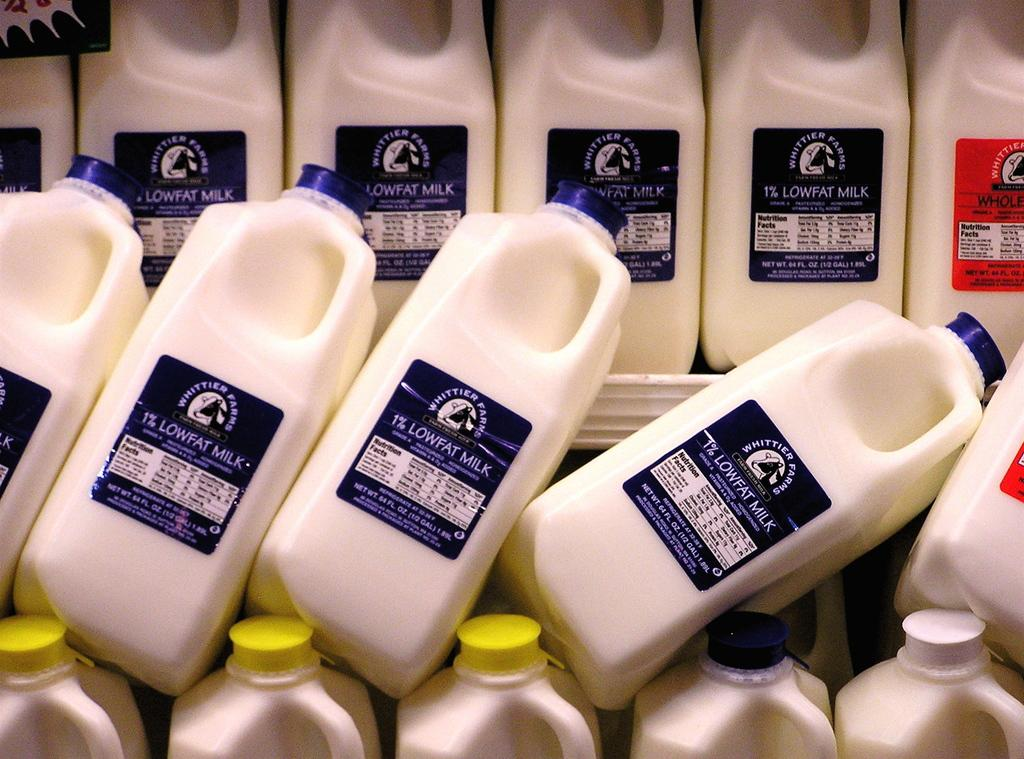<image>
Give a short and clear explanation of the subsequent image. A display of milk of various fat percentages. 